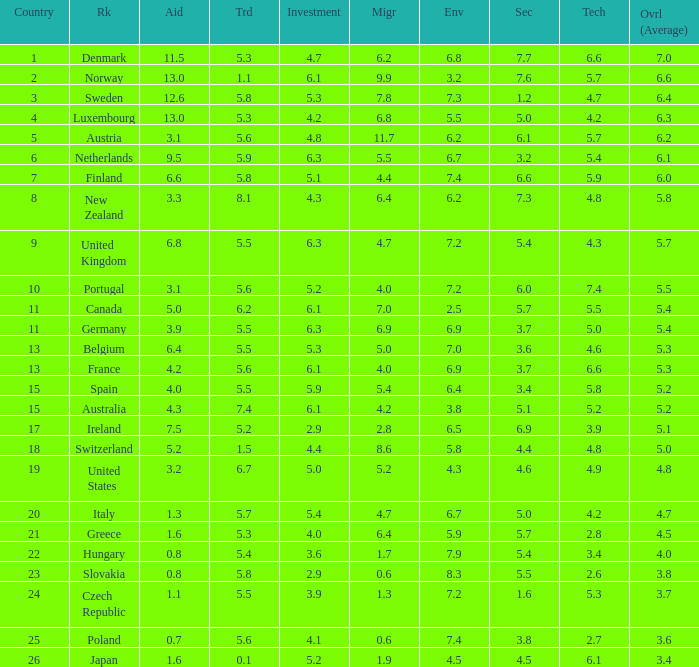What is the migration rating when trade is 5.7? 4.7. Give me the full table as a dictionary. {'header': ['Country', 'Rk', 'Aid', 'Trd', 'Investment', 'Migr', 'Env', 'Sec', 'Tech', 'Ovrl (Average)'], 'rows': [['1', 'Denmark', '11.5', '5.3', '4.7', '6.2', '6.8', '7.7', '6.6', '7.0'], ['2', 'Norway', '13.0', '1.1', '6.1', '9.9', '3.2', '7.6', '5.7', '6.6'], ['3', 'Sweden', '12.6', '5.8', '5.3', '7.8', '7.3', '1.2', '4.7', '6.4'], ['4', 'Luxembourg', '13.0', '5.3', '4.2', '6.8', '5.5', '5.0', '4.2', '6.3'], ['5', 'Austria', '3.1', '5.6', '4.8', '11.7', '6.2', '6.1', '5.7', '6.2'], ['6', 'Netherlands', '9.5', '5.9', '6.3', '5.5', '6.7', '3.2', '5.4', '6.1'], ['7', 'Finland', '6.6', '5.8', '5.1', '4.4', '7.4', '6.6', '5.9', '6.0'], ['8', 'New Zealand', '3.3', '8.1', '4.3', '6.4', '6.2', '7.3', '4.8', '5.8'], ['9', 'United Kingdom', '6.8', '5.5', '6.3', '4.7', '7.2', '5.4', '4.3', '5.7'], ['10', 'Portugal', '3.1', '5.6', '5.2', '4.0', '7.2', '6.0', '7.4', '5.5'], ['11', 'Canada', '5.0', '6.2', '6.1', '7.0', '2.5', '5.7', '5.5', '5.4'], ['11', 'Germany', '3.9', '5.5', '6.3', '6.9', '6.9', '3.7', '5.0', '5.4'], ['13', 'Belgium', '6.4', '5.5', '5.3', '5.0', '7.0', '3.6', '4.6', '5.3'], ['13', 'France', '4.2', '5.6', '6.1', '4.0', '6.9', '3.7', '6.6', '5.3'], ['15', 'Spain', '4.0', '5.5', '5.9', '5.4', '6.4', '3.4', '5.8', '5.2'], ['15', 'Australia', '4.3', '7.4', '6.1', '4.2', '3.8', '5.1', '5.2', '5.2'], ['17', 'Ireland', '7.5', '5.2', '2.9', '2.8', '6.5', '6.9', '3.9', '5.1'], ['18', 'Switzerland', '5.2', '1.5', '4.4', '8.6', '5.8', '4.4', '4.8', '5.0'], ['19', 'United States', '3.2', '6.7', '5.0', '5.2', '4.3', '4.6', '4.9', '4.8'], ['20', 'Italy', '1.3', '5.7', '5.4', '4.7', '6.7', '5.0', '4.2', '4.7'], ['21', 'Greece', '1.6', '5.3', '4.0', '6.4', '5.9', '5.7', '2.8', '4.5'], ['22', 'Hungary', '0.8', '5.4', '3.6', '1.7', '7.9', '5.4', '3.4', '4.0'], ['23', 'Slovakia', '0.8', '5.8', '2.9', '0.6', '8.3', '5.5', '2.6', '3.8'], ['24', 'Czech Republic', '1.1', '5.5', '3.9', '1.3', '7.2', '1.6', '5.3', '3.7'], ['25', 'Poland', '0.7', '5.6', '4.1', '0.6', '7.4', '3.8', '2.7', '3.6'], ['26', 'Japan', '1.6', '0.1', '5.2', '1.9', '4.5', '4.5', '6.1', '3.4']]} 